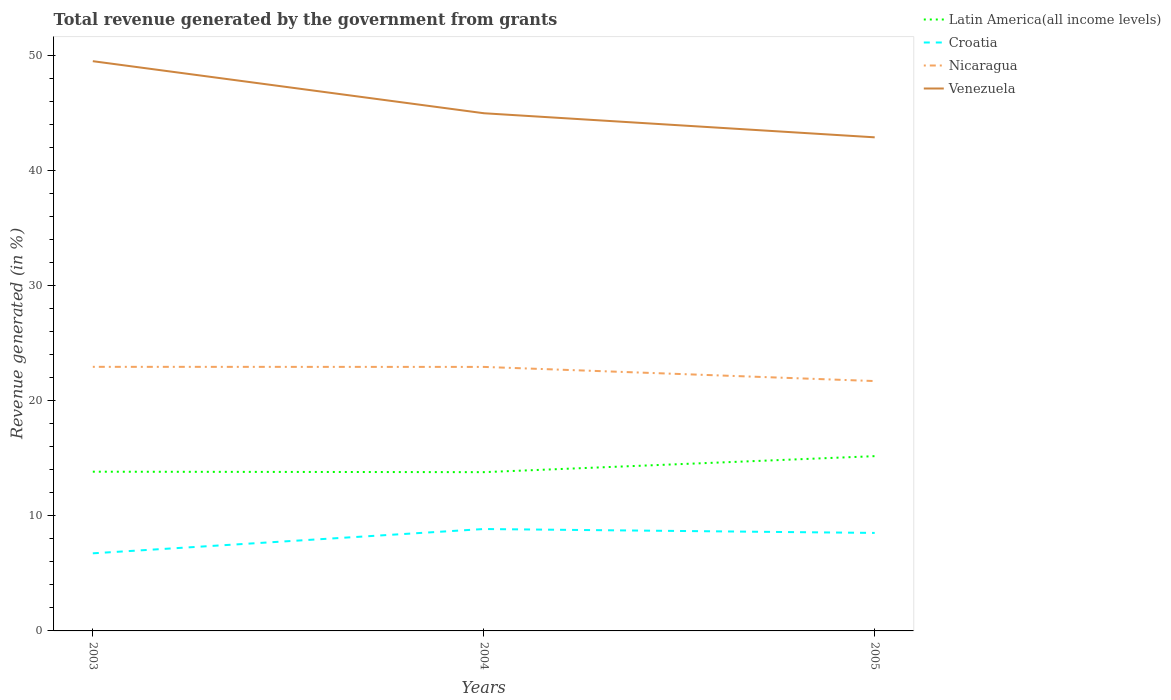Across all years, what is the maximum total revenue generated in Nicaragua?
Offer a very short reply. 21.72. In which year was the total revenue generated in Venezuela maximum?
Ensure brevity in your answer.  2005. What is the total total revenue generated in Latin America(all income levels) in the graph?
Ensure brevity in your answer.  -1.35. What is the difference between the highest and the second highest total revenue generated in Nicaragua?
Offer a terse response. 1.24. Is the total revenue generated in Venezuela strictly greater than the total revenue generated in Nicaragua over the years?
Your answer should be compact. No. What is the difference between two consecutive major ticks on the Y-axis?
Offer a very short reply. 10. Are the values on the major ticks of Y-axis written in scientific E-notation?
Your answer should be very brief. No. Does the graph contain any zero values?
Provide a short and direct response. No. How many legend labels are there?
Your response must be concise. 4. How are the legend labels stacked?
Offer a very short reply. Vertical. What is the title of the graph?
Your answer should be compact. Total revenue generated by the government from grants. What is the label or title of the Y-axis?
Provide a succinct answer. Revenue generated (in %). What is the Revenue generated (in %) in Latin America(all income levels) in 2003?
Your answer should be compact. 13.84. What is the Revenue generated (in %) in Croatia in 2003?
Your answer should be very brief. 6.75. What is the Revenue generated (in %) of Nicaragua in 2003?
Your answer should be very brief. 22.96. What is the Revenue generated (in %) of Venezuela in 2003?
Provide a succinct answer. 49.53. What is the Revenue generated (in %) of Latin America(all income levels) in 2004?
Ensure brevity in your answer.  13.8. What is the Revenue generated (in %) of Croatia in 2004?
Provide a short and direct response. 8.86. What is the Revenue generated (in %) of Nicaragua in 2004?
Give a very brief answer. 22.95. What is the Revenue generated (in %) of Venezuela in 2004?
Your response must be concise. 45. What is the Revenue generated (in %) of Latin America(all income levels) in 2005?
Keep it short and to the point. 15.19. What is the Revenue generated (in %) of Croatia in 2005?
Make the answer very short. 8.52. What is the Revenue generated (in %) in Nicaragua in 2005?
Your response must be concise. 21.72. What is the Revenue generated (in %) of Venezuela in 2005?
Make the answer very short. 42.91. Across all years, what is the maximum Revenue generated (in %) in Latin America(all income levels)?
Offer a terse response. 15.19. Across all years, what is the maximum Revenue generated (in %) of Croatia?
Make the answer very short. 8.86. Across all years, what is the maximum Revenue generated (in %) in Nicaragua?
Give a very brief answer. 22.96. Across all years, what is the maximum Revenue generated (in %) of Venezuela?
Offer a terse response. 49.53. Across all years, what is the minimum Revenue generated (in %) of Latin America(all income levels)?
Provide a short and direct response. 13.8. Across all years, what is the minimum Revenue generated (in %) of Croatia?
Provide a succinct answer. 6.75. Across all years, what is the minimum Revenue generated (in %) of Nicaragua?
Offer a very short reply. 21.72. Across all years, what is the minimum Revenue generated (in %) of Venezuela?
Your answer should be compact. 42.91. What is the total Revenue generated (in %) of Latin America(all income levels) in the graph?
Provide a short and direct response. 42.84. What is the total Revenue generated (in %) of Croatia in the graph?
Give a very brief answer. 24.12. What is the total Revenue generated (in %) in Nicaragua in the graph?
Your answer should be very brief. 67.63. What is the total Revenue generated (in %) of Venezuela in the graph?
Ensure brevity in your answer.  137.44. What is the difference between the Revenue generated (in %) in Latin America(all income levels) in 2003 and that in 2004?
Your response must be concise. 0.04. What is the difference between the Revenue generated (in %) of Croatia in 2003 and that in 2004?
Give a very brief answer. -2.11. What is the difference between the Revenue generated (in %) in Nicaragua in 2003 and that in 2004?
Give a very brief answer. 0.01. What is the difference between the Revenue generated (in %) in Venezuela in 2003 and that in 2004?
Keep it short and to the point. 4.52. What is the difference between the Revenue generated (in %) in Latin America(all income levels) in 2003 and that in 2005?
Your response must be concise. -1.35. What is the difference between the Revenue generated (in %) of Croatia in 2003 and that in 2005?
Your answer should be compact. -1.77. What is the difference between the Revenue generated (in %) in Nicaragua in 2003 and that in 2005?
Provide a succinct answer. 1.24. What is the difference between the Revenue generated (in %) of Venezuela in 2003 and that in 2005?
Your answer should be compact. 6.62. What is the difference between the Revenue generated (in %) in Latin America(all income levels) in 2004 and that in 2005?
Offer a very short reply. -1.39. What is the difference between the Revenue generated (in %) of Croatia in 2004 and that in 2005?
Your response must be concise. 0.34. What is the difference between the Revenue generated (in %) of Nicaragua in 2004 and that in 2005?
Offer a very short reply. 1.23. What is the difference between the Revenue generated (in %) in Venezuela in 2004 and that in 2005?
Provide a succinct answer. 2.09. What is the difference between the Revenue generated (in %) in Latin America(all income levels) in 2003 and the Revenue generated (in %) in Croatia in 2004?
Ensure brevity in your answer.  4.98. What is the difference between the Revenue generated (in %) of Latin America(all income levels) in 2003 and the Revenue generated (in %) of Nicaragua in 2004?
Provide a succinct answer. -9.11. What is the difference between the Revenue generated (in %) of Latin America(all income levels) in 2003 and the Revenue generated (in %) of Venezuela in 2004?
Your answer should be compact. -31.16. What is the difference between the Revenue generated (in %) of Croatia in 2003 and the Revenue generated (in %) of Nicaragua in 2004?
Keep it short and to the point. -16.21. What is the difference between the Revenue generated (in %) of Croatia in 2003 and the Revenue generated (in %) of Venezuela in 2004?
Provide a short and direct response. -38.26. What is the difference between the Revenue generated (in %) of Nicaragua in 2003 and the Revenue generated (in %) of Venezuela in 2004?
Offer a very short reply. -22.05. What is the difference between the Revenue generated (in %) of Latin America(all income levels) in 2003 and the Revenue generated (in %) of Croatia in 2005?
Keep it short and to the point. 5.32. What is the difference between the Revenue generated (in %) in Latin America(all income levels) in 2003 and the Revenue generated (in %) in Nicaragua in 2005?
Ensure brevity in your answer.  -7.88. What is the difference between the Revenue generated (in %) in Latin America(all income levels) in 2003 and the Revenue generated (in %) in Venezuela in 2005?
Your answer should be very brief. -29.07. What is the difference between the Revenue generated (in %) of Croatia in 2003 and the Revenue generated (in %) of Nicaragua in 2005?
Provide a short and direct response. -14.97. What is the difference between the Revenue generated (in %) in Croatia in 2003 and the Revenue generated (in %) in Venezuela in 2005?
Make the answer very short. -36.16. What is the difference between the Revenue generated (in %) in Nicaragua in 2003 and the Revenue generated (in %) in Venezuela in 2005?
Your answer should be compact. -19.95. What is the difference between the Revenue generated (in %) in Latin America(all income levels) in 2004 and the Revenue generated (in %) in Croatia in 2005?
Make the answer very short. 5.28. What is the difference between the Revenue generated (in %) of Latin America(all income levels) in 2004 and the Revenue generated (in %) of Nicaragua in 2005?
Offer a terse response. -7.92. What is the difference between the Revenue generated (in %) in Latin America(all income levels) in 2004 and the Revenue generated (in %) in Venezuela in 2005?
Offer a very short reply. -29.11. What is the difference between the Revenue generated (in %) of Croatia in 2004 and the Revenue generated (in %) of Nicaragua in 2005?
Your answer should be compact. -12.86. What is the difference between the Revenue generated (in %) in Croatia in 2004 and the Revenue generated (in %) in Venezuela in 2005?
Give a very brief answer. -34.05. What is the difference between the Revenue generated (in %) in Nicaragua in 2004 and the Revenue generated (in %) in Venezuela in 2005?
Your answer should be compact. -19.96. What is the average Revenue generated (in %) in Latin America(all income levels) per year?
Your response must be concise. 14.28. What is the average Revenue generated (in %) in Croatia per year?
Keep it short and to the point. 8.04. What is the average Revenue generated (in %) in Nicaragua per year?
Offer a terse response. 22.54. What is the average Revenue generated (in %) of Venezuela per year?
Make the answer very short. 45.81. In the year 2003, what is the difference between the Revenue generated (in %) of Latin America(all income levels) and Revenue generated (in %) of Croatia?
Ensure brevity in your answer.  7.1. In the year 2003, what is the difference between the Revenue generated (in %) in Latin America(all income levels) and Revenue generated (in %) in Nicaragua?
Keep it short and to the point. -9.12. In the year 2003, what is the difference between the Revenue generated (in %) of Latin America(all income levels) and Revenue generated (in %) of Venezuela?
Offer a terse response. -35.69. In the year 2003, what is the difference between the Revenue generated (in %) of Croatia and Revenue generated (in %) of Nicaragua?
Offer a very short reply. -16.21. In the year 2003, what is the difference between the Revenue generated (in %) of Croatia and Revenue generated (in %) of Venezuela?
Your answer should be very brief. -42.78. In the year 2003, what is the difference between the Revenue generated (in %) of Nicaragua and Revenue generated (in %) of Venezuela?
Give a very brief answer. -26.57. In the year 2004, what is the difference between the Revenue generated (in %) of Latin America(all income levels) and Revenue generated (in %) of Croatia?
Make the answer very short. 4.94. In the year 2004, what is the difference between the Revenue generated (in %) of Latin America(all income levels) and Revenue generated (in %) of Nicaragua?
Your answer should be very brief. -9.15. In the year 2004, what is the difference between the Revenue generated (in %) of Latin America(all income levels) and Revenue generated (in %) of Venezuela?
Provide a short and direct response. -31.2. In the year 2004, what is the difference between the Revenue generated (in %) in Croatia and Revenue generated (in %) in Nicaragua?
Your answer should be very brief. -14.09. In the year 2004, what is the difference between the Revenue generated (in %) in Croatia and Revenue generated (in %) in Venezuela?
Offer a very short reply. -36.14. In the year 2004, what is the difference between the Revenue generated (in %) of Nicaragua and Revenue generated (in %) of Venezuela?
Keep it short and to the point. -22.05. In the year 2005, what is the difference between the Revenue generated (in %) of Latin America(all income levels) and Revenue generated (in %) of Croatia?
Provide a short and direct response. 6.67. In the year 2005, what is the difference between the Revenue generated (in %) in Latin America(all income levels) and Revenue generated (in %) in Nicaragua?
Offer a terse response. -6.53. In the year 2005, what is the difference between the Revenue generated (in %) of Latin America(all income levels) and Revenue generated (in %) of Venezuela?
Ensure brevity in your answer.  -27.72. In the year 2005, what is the difference between the Revenue generated (in %) in Croatia and Revenue generated (in %) in Nicaragua?
Offer a terse response. -13.2. In the year 2005, what is the difference between the Revenue generated (in %) in Croatia and Revenue generated (in %) in Venezuela?
Provide a short and direct response. -34.39. In the year 2005, what is the difference between the Revenue generated (in %) in Nicaragua and Revenue generated (in %) in Venezuela?
Offer a very short reply. -21.19. What is the ratio of the Revenue generated (in %) of Croatia in 2003 to that in 2004?
Offer a terse response. 0.76. What is the ratio of the Revenue generated (in %) in Nicaragua in 2003 to that in 2004?
Offer a terse response. 1. What is the ratio of the Revenue generated (in %) in Venezuela in 2003 to that in 2004?
Offer a very short reply. 1.1. What is the ratio of the Revenue generated (in %) of Latin America(all income levels) in 2003 to that in 2005?
Provide a short and direct response. 0.91. What is the ratio of the Revenue generated (in %) in Croatia in 2003 to that in 2005?
Give a very brief answer. 0.79. What is the ratio of the Revenue generated (in %) of Nicaragua in 2003 to that in 2005?
Your response must be concise. 1.06. What is the ratio of the Revenue generated (in %) of Venezuela in 2003 to that in 2005?
Provide a succinct answer. 1.15. What is the ratio of the Revenue generated (in %) in Latin America(all income levels) in 2004 to that in 2005?
Your answer should be compact. 0.91. What is the ratio of the Revenue generated (in %) of Croatia in 2004 to that in 2005?
Your response must be concise. 1.04. What is the ratio of the Revenue generated (in %) in Nicaragua in 2004 to that in 2005?
Provide a succinct answer. 1.06. What is the ratio of the Revenue generated (in %) in Venezuela in 2004 to that in 2005?
Your answer should be very brief. 1.05. What is the difference between the highest and the second highest Revenue generated (in %) of Latin America(all income levels)?
Your answer should be very brief. 1.35. What is the difference between the highest and the second highest Revenue generated (in %) of Croatia?
Keep it short and to the point. 0.34. What is the difference between the highest and the second highest Revenue generated (in %) of Nicaragua?
Make the answer very short. 0.01. What is the difference between the highest and the second highest Revenue generated (in %) in Venezuela?
Provide a short and direct response. 4.52. What is the difference between the highest and the lowest Revenue generated (in %) of Latin America(all income levels)?
Offer a terse response. 1.39. What is the difference between the highest and the lowest Revenue generated (in %) in Croatia?
Offer a very short reply. 2.11. What is the difference between the highest and the lowest Revenue generated (in %) in Nicaragua?
Provide a short and direct response. 1.24. What is the difference between the highest and the lowest Revenue generated (in %) in Venezuela?
Provide a short and direct response. 6.62. 